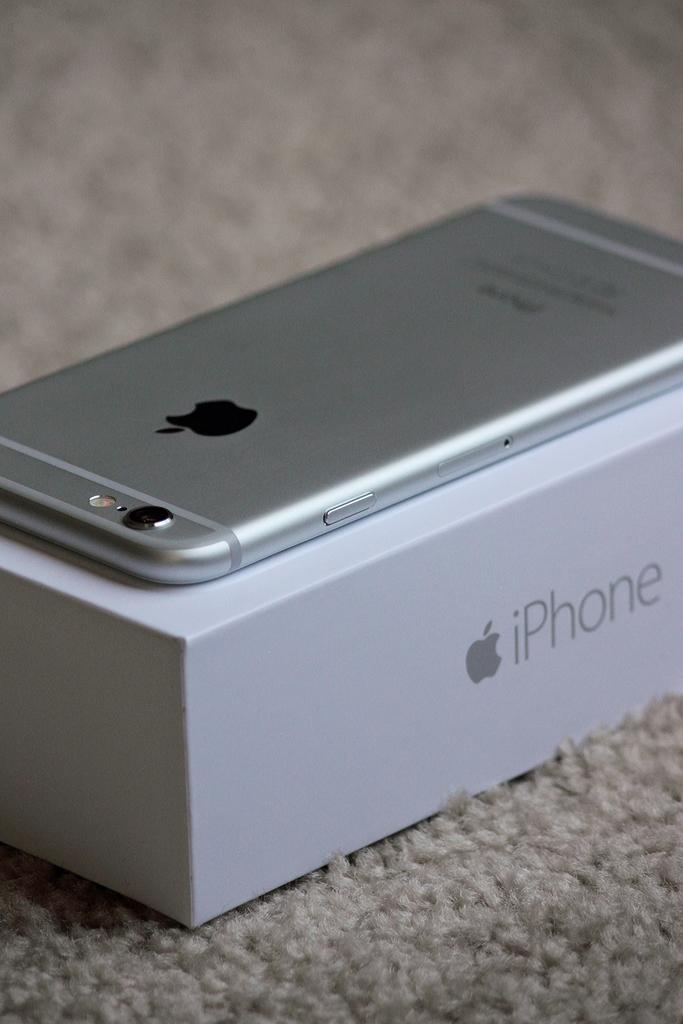Provide a one-sentence caption for the provided image. A silver iPhone sits on top of an iPhone box. 